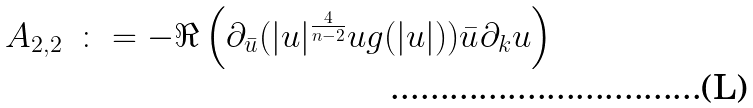<formula> <loc_0><loc_0><loc_500><loc_500>\begin{array} { l l } A _ { 2 , 2 } & \colon = - \Re \left ( \partial _ { \bar { u } } ( | u | ^ { \frac { 4 } { n - 2 } } u g ( | u | ) ) \bar { u } \partial _ { k } u \right ) \end{array}</formula> 